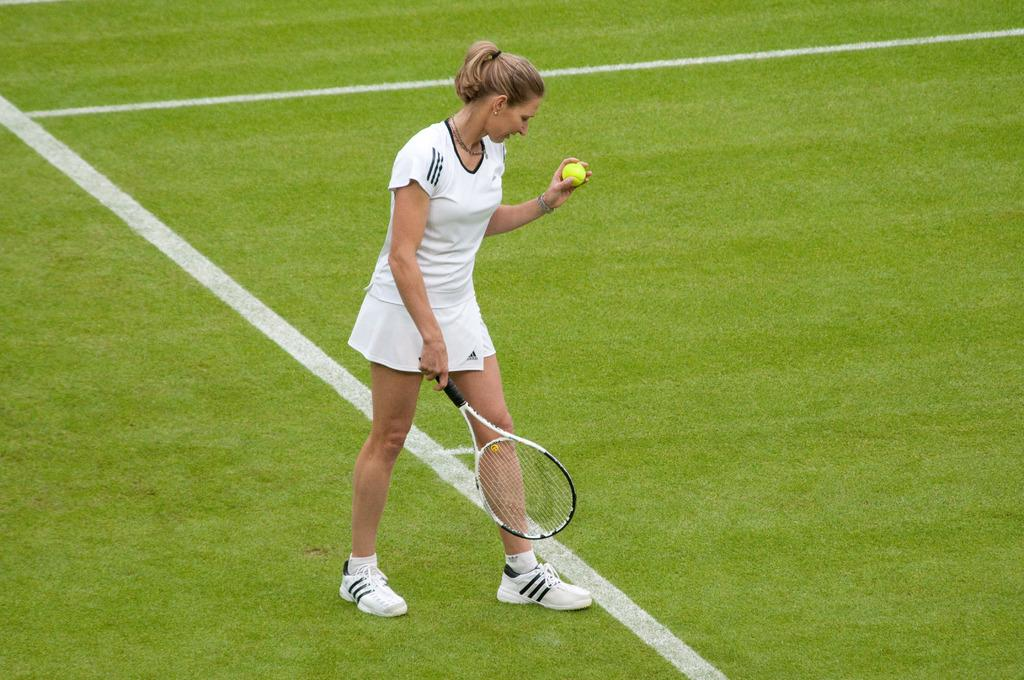Who is present in the image? There is a woman in the picture. What is the woman wearing? The woman is wearing a white dress and shoes. What accessory is the woman wearing? The woman is wearing a locket. What is the woman holding in her hands? The woman is holding a racket and a tennis ball. What is the woman standing on? The woman is standing on the ground. What type of vegetation can be seen on the left side of the image? There is grass on the left side of the image. Can you see the woman's friend playing with a plastic toy in the image? There is no friend or plastic toy present in the image; it only features the woman with a racket and a tennis ball. 